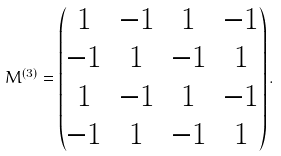Convert formula to latex. <formula><loc_0><loc_0><loc_500><loc_500>M ^ { ( 3 ) } = \begin{pmatrix} 1 & - 1 & 1 & - 1 \\ - 1 & 1 & - 1 & 1 \\ 1 & - 1 & 1 & - 1 \\ - 1 & 1 & - 1 & 1 \end{pmatrix} .</formula> 